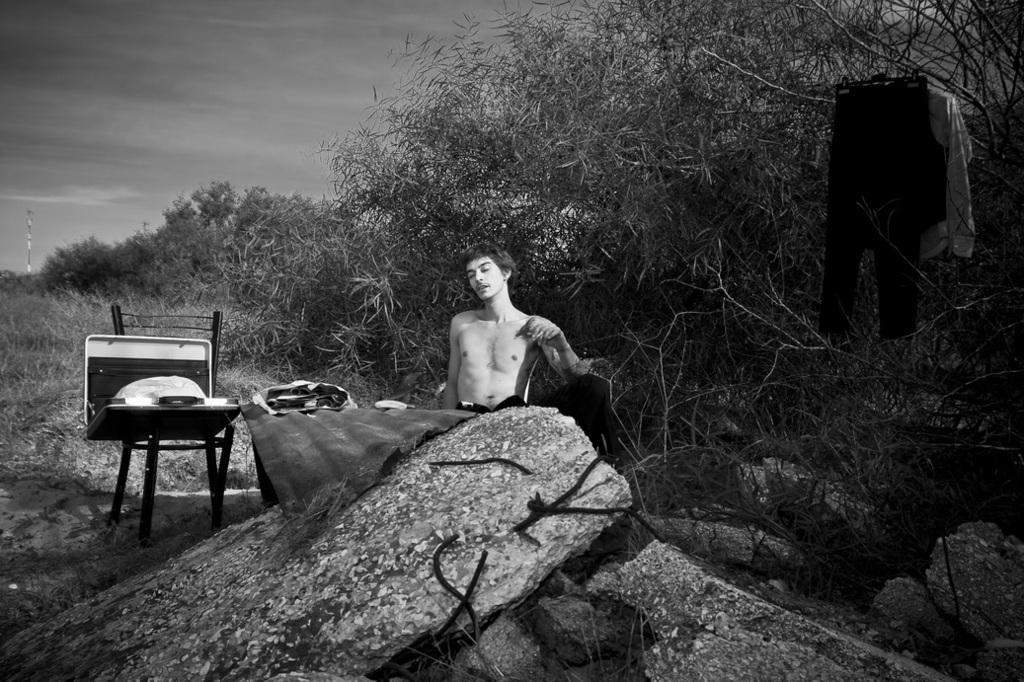Could you give a brief overview of what you see in this image? In the center of the image there is a man sitting. On the left there is a chair and we can see briefcase placed on it. At the bottom there are rocks. In the background there are trees, clothes and sky. 